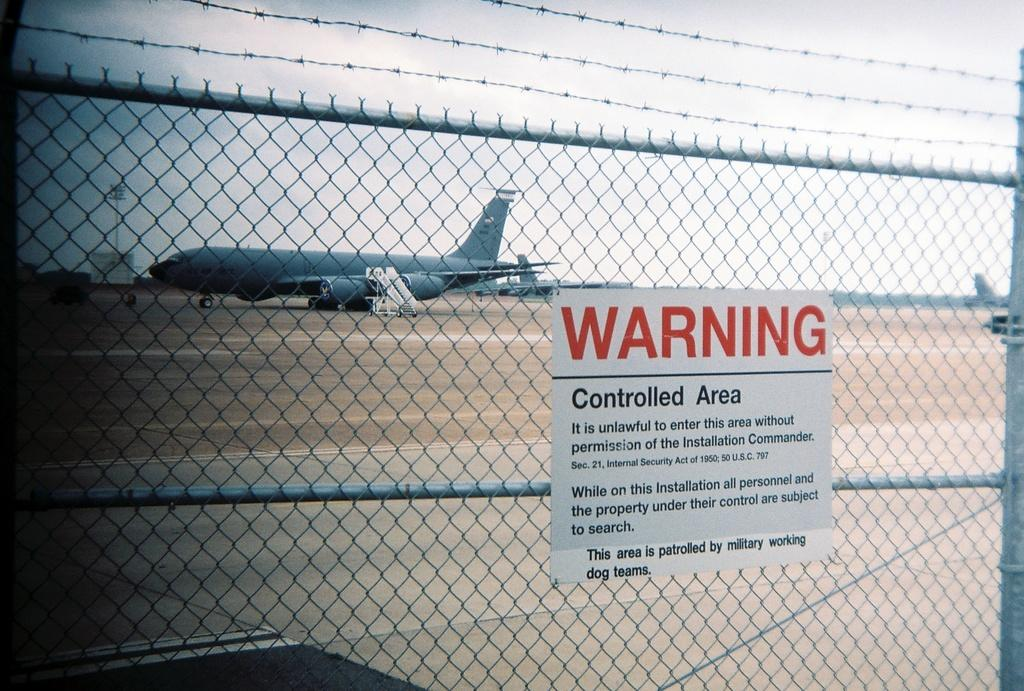<image>
Share a concise interpretation of the image provided. An airport with a jet in the background and a fence with a Warning sign on it. 